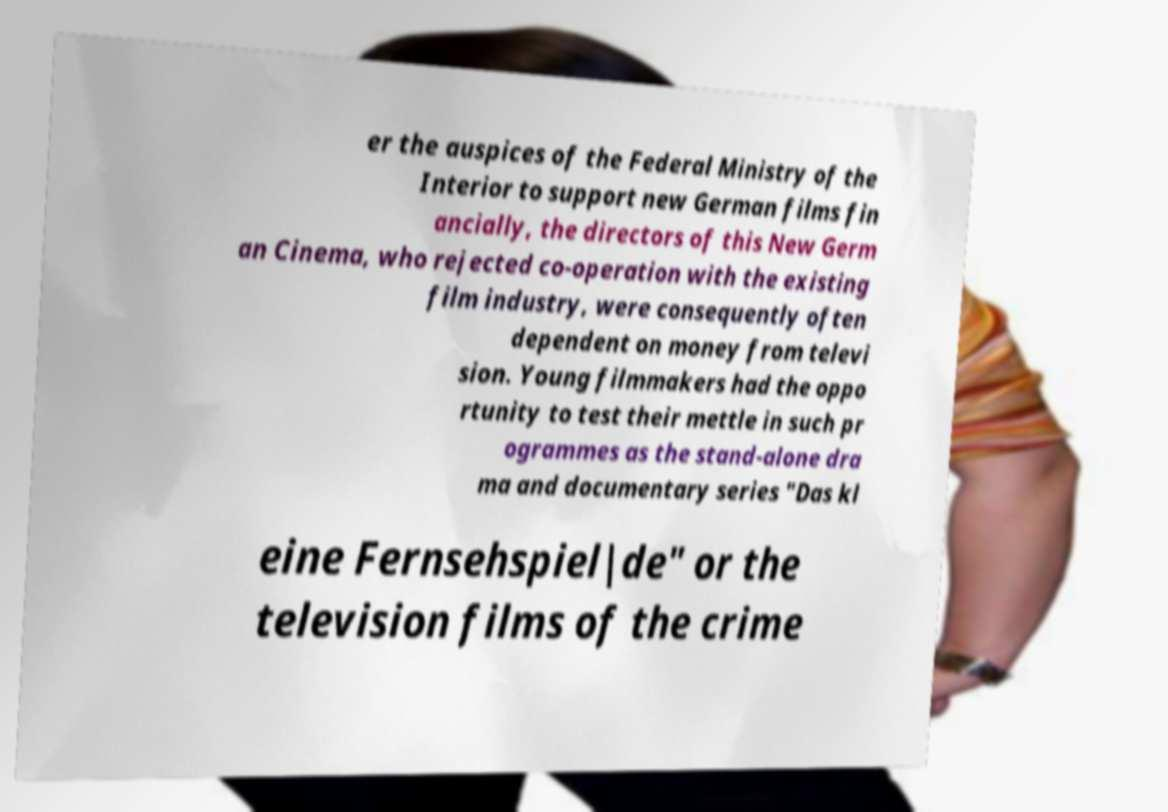Can you read and provide the text displayed in the image?This photo seems to have some interesting text. Can you extract and type it out for me? er the auspices of the Federal Ministry of the Interior to support new German films fin ancially, the directors of this New Germ an Cinema, who rejected co-operation with the existing film industry, were consequently often dependent on money from televi sion. Young filmmakers had the oppo rtunity to test their mettle in such pr ogrammes as the stand-alone dra ma and documentary series "Das kl eine Fernsehspiel|de" or the television films of the crime 